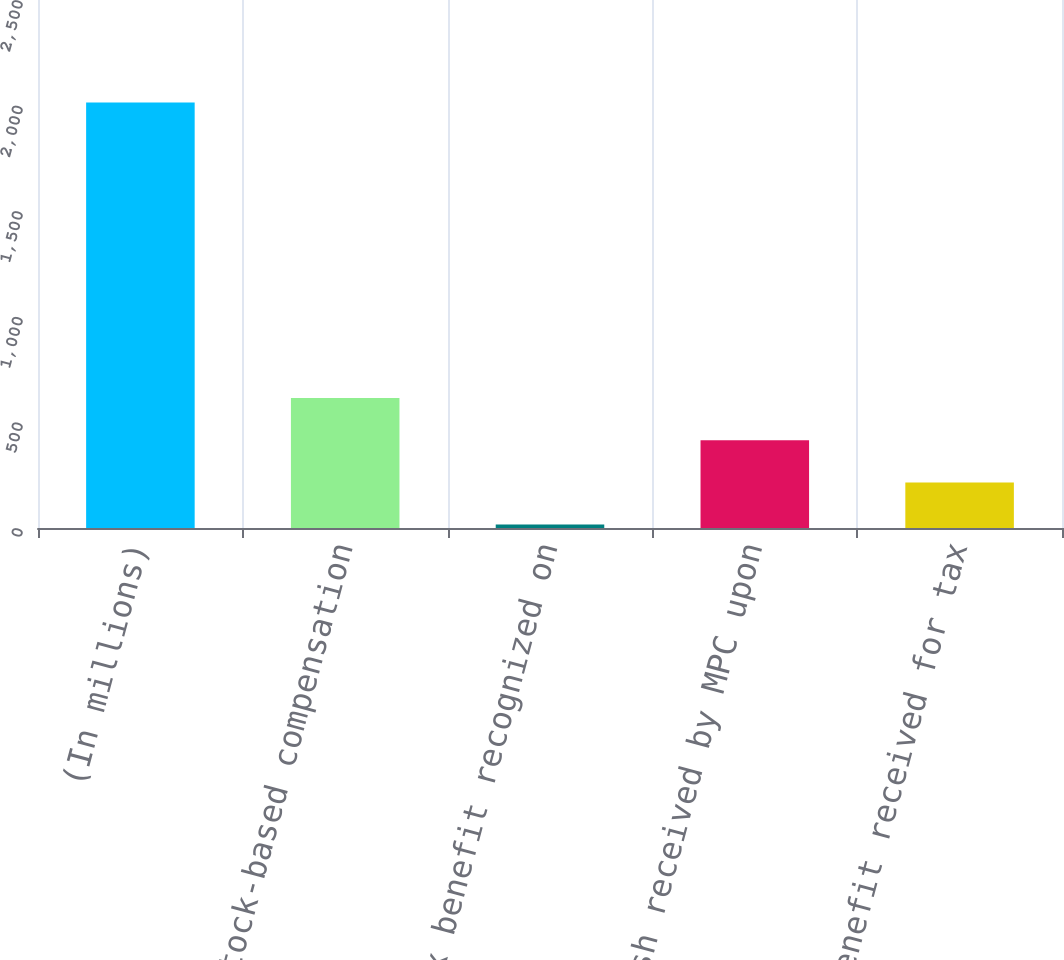Convert chart. <chart><loc_0><loc_0><loc_500><loc_500><bar_chart><fcel>(In millions)<fcel>Stock-based compensation<fcel>Tax benefit recognized on<fcel>Cash received by MPC upon<fcel>Tax benefit received for tax<nl><fcel>2015<fcel>615.7<fcel>16<fcel>415.8<fcel>215.9<nl></chart> 